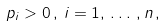Convert formula to latex. <formula><loc_0><loc_0><loc_500><loc_500>p _ { i } > 0 \, , \, i = 1 , \, \dots \, , n \, ,</formula> 